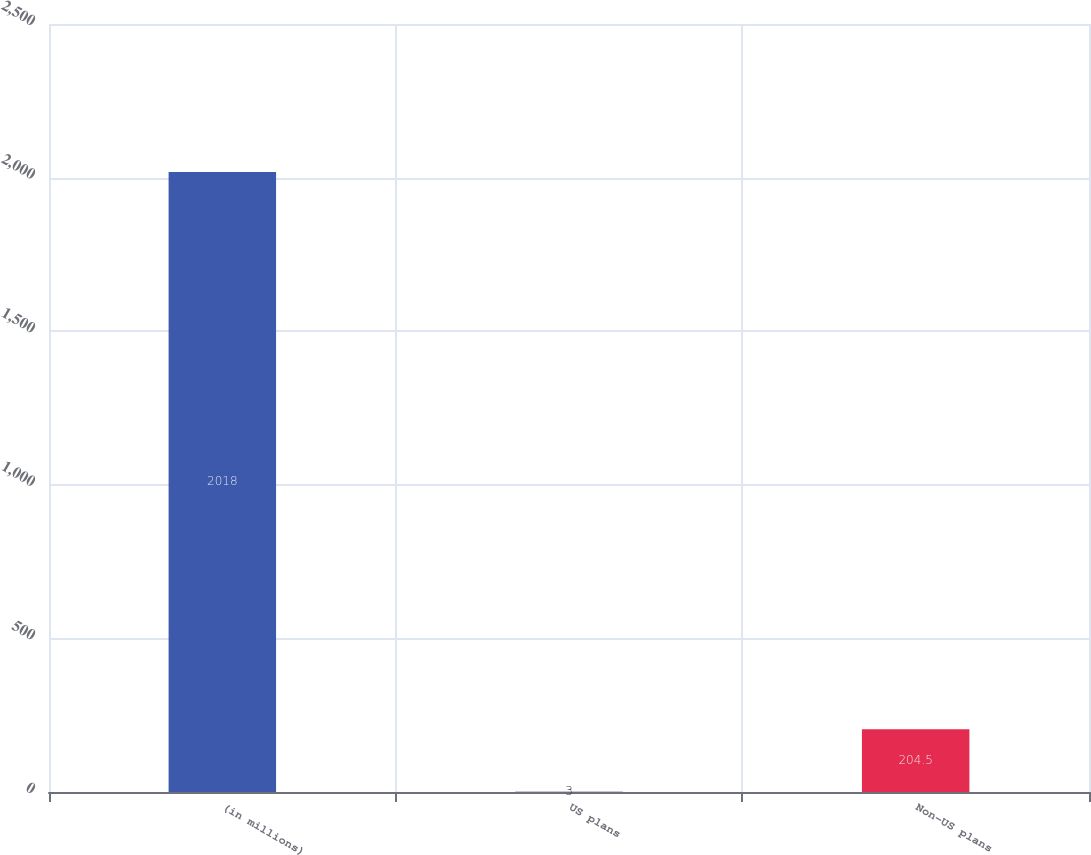Convert chart to OTSL. <chart><loc_0><loc_0><loc_500><loc_500><bar_chart><fcel>(in millions)<fcel>US plans<fcel>Non-US plans<nl><fcel>2018<fcel>3<fcel>204.5<nl></chart> 